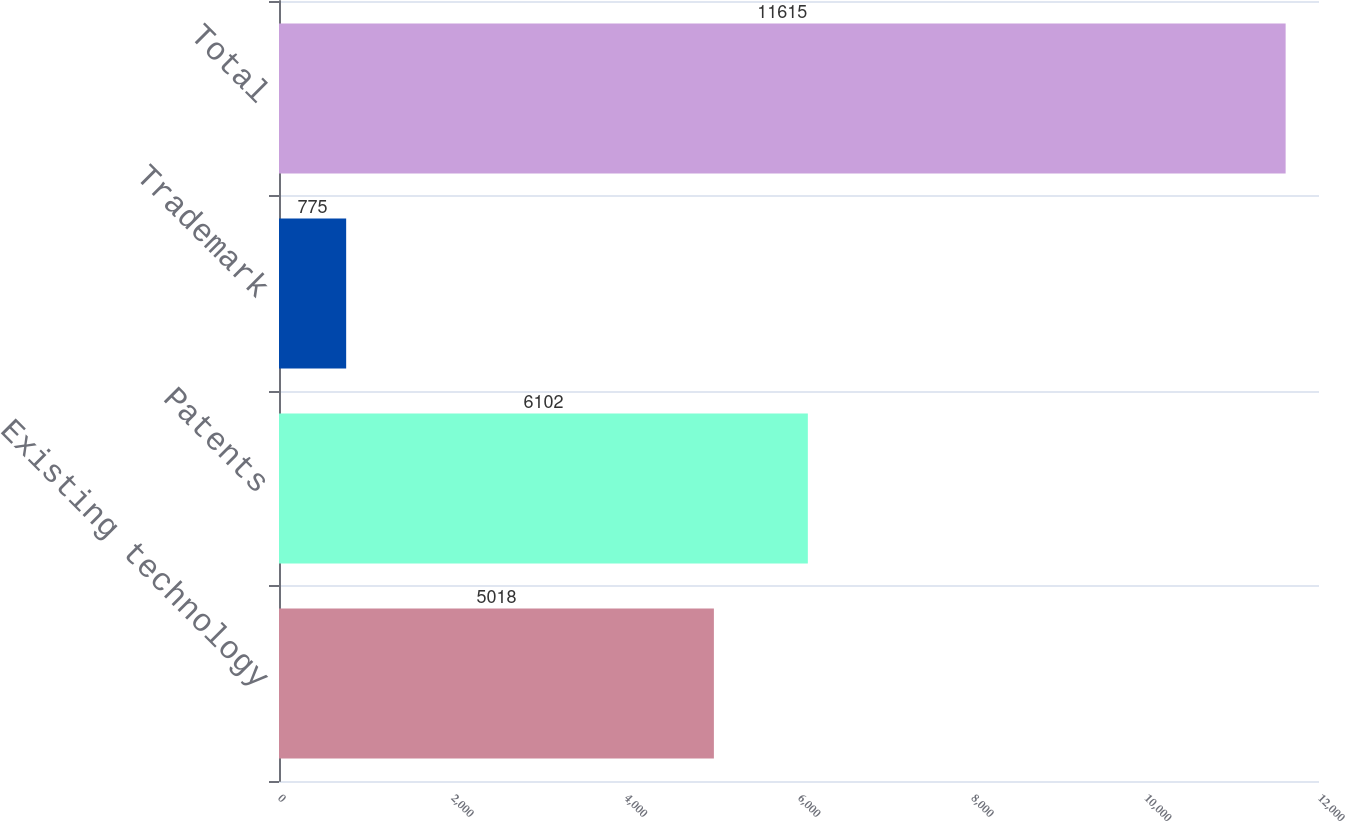Convert chart. <chart><loc_0><loc_0><loc_500><loc_500><bar_chart><fcel>Existing technology<fcel>Patents<fcel>Trademark<fcel>Total<nl><fcel>5018<fcel>6102<fcel>775<fcel>11615<nl></chart> 